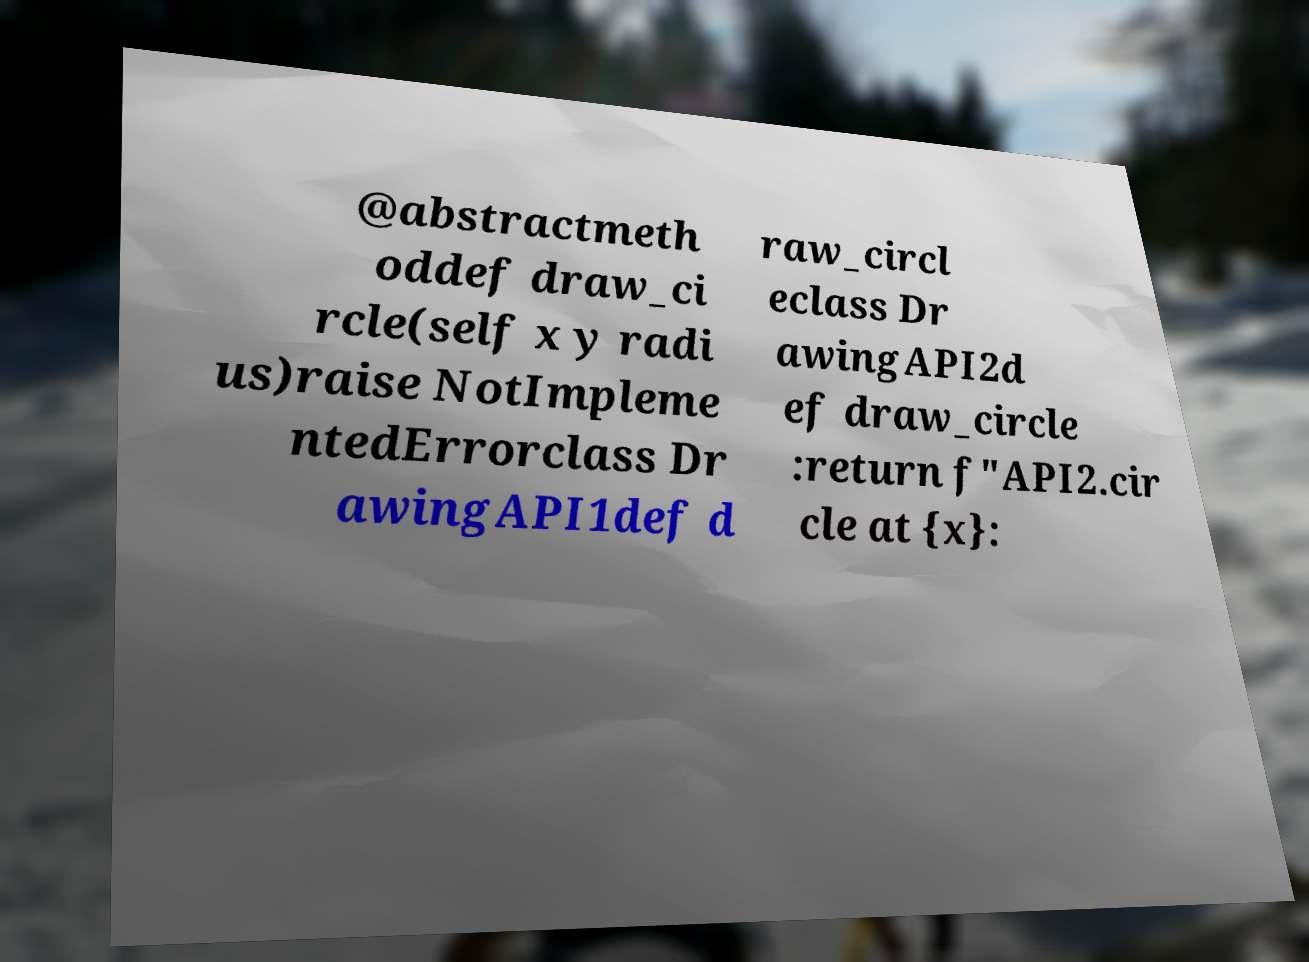For documentation purposes, I need the text within this image transcribed. Could you provide that? @abstractmeth oddef draw_ci rcle(self x y radi us)raise NotImpleme ntedErrorclass Dr awingAPI1def d raw_circl eclass Dr awingAPI2d ef draw_circle :return f"API2.cir cle at {x}: 